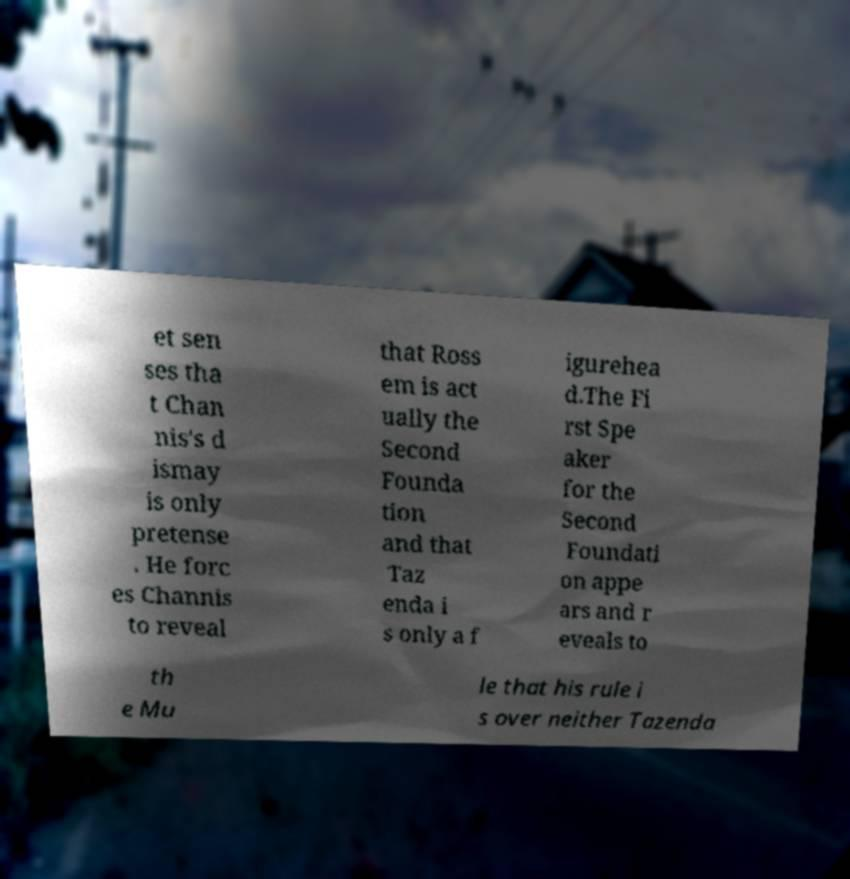There's text embedded in this image that I need extracted. Can you transcribe it verbatim? et sen ses tha t Chan nis's d ismay is only pretense . He forc es Channis to reveal that Ross em is act ually the Second Founda tion and that Taz enda i s only a f igurehea d.The Fi rst Spe aker for the Second Foundati on appe ars and r eveals to th e Mu le that his rule i s over neither Tazenda 